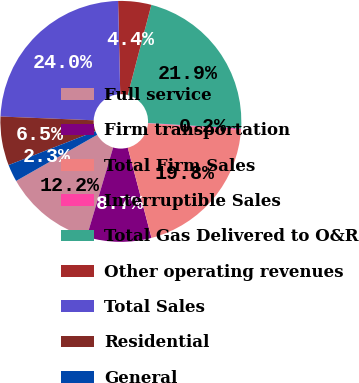Convert chart. <chart><loc_0><loc_0><loc_500><loc_500><pie_chart><fcel>Full service<fcel>Firm transportation<fcel>Total Firm Sales<fcel>Interruptible Sales<fcel>Total Gas Delivered to O&R<fcel>Other operating revenues<fcel>Total Sales<fcel>Residential<fcel>General<nl><fcel>12.2%<fcel>8.67%<fcel>19.76%<fcel>0.2%<fcel>21.88%<fcel>4.44%<fcel>23.99%<fcel>6.55%<fcel>2.32%<nl></chart> 